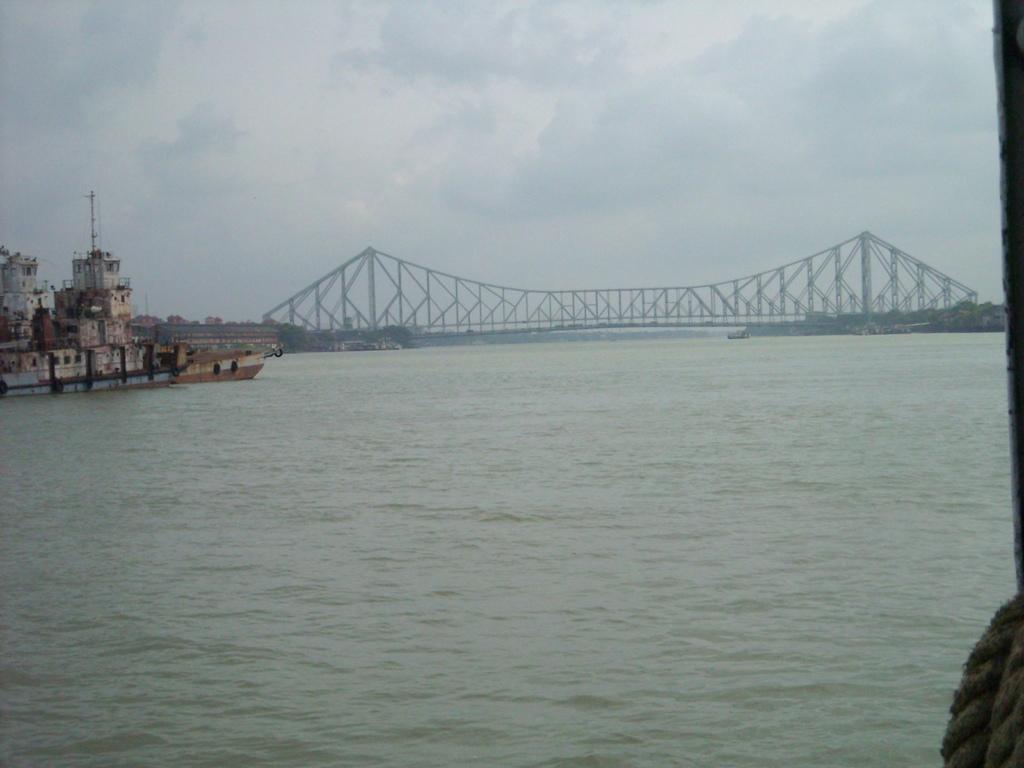Describe this image in one or two sentences. In the image we can see the sea and a bridge. Here we can see the ship in the water, rope and a cloudy sky. We can see there are even buildings. 